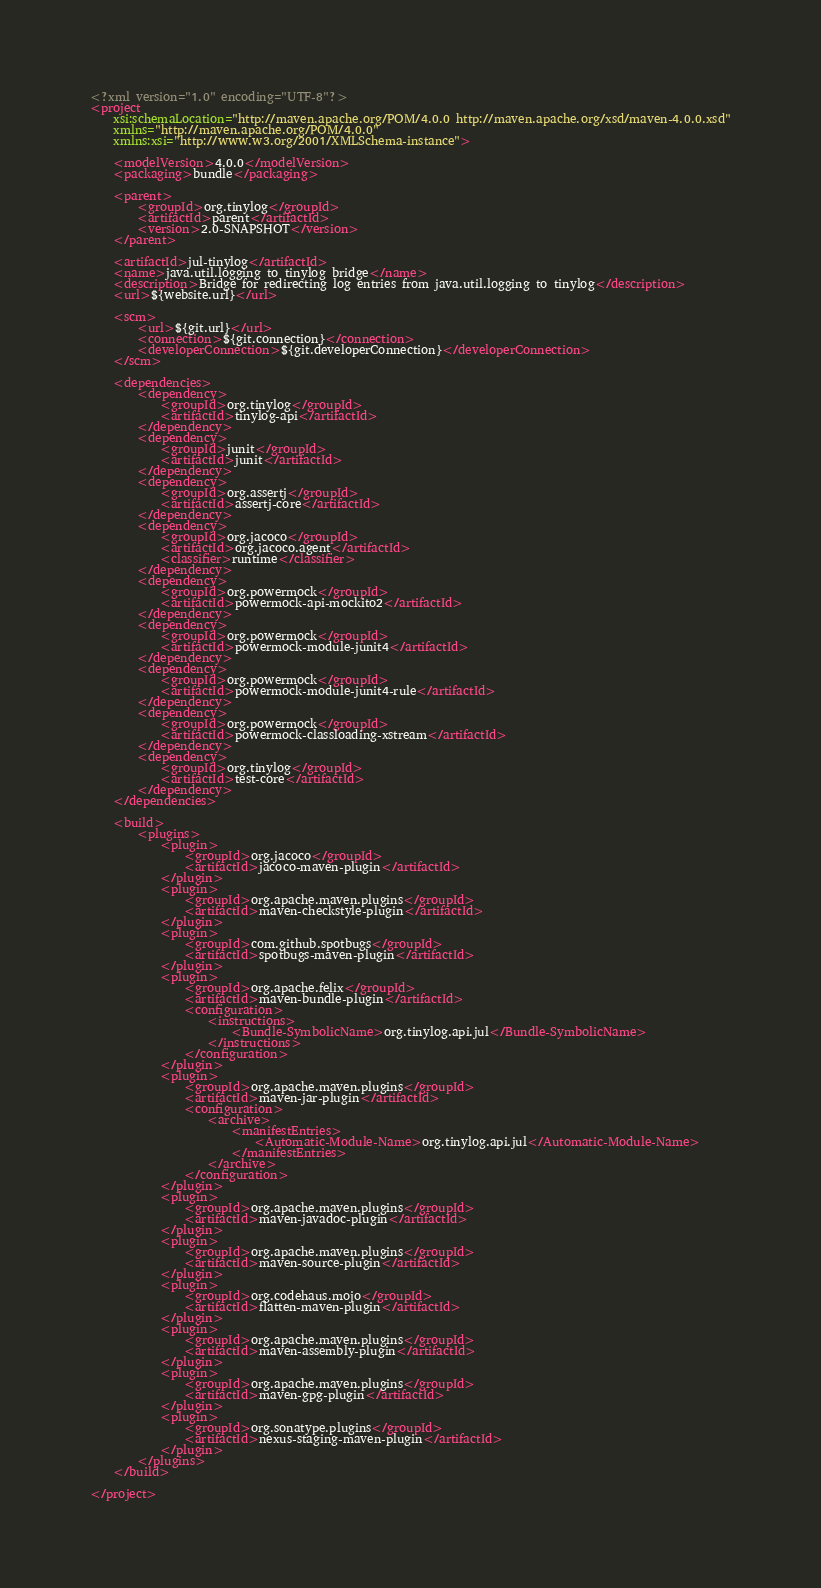Convert code to text. <code><loc_0><loc_0><loc_500><loc_500><_XML_><?xml version="1.0" encoding="UTF-8"?>
<project
	xsi:schemaLocation="http://maven.apache.org/POM/4.0.0 http://maven.apache.org/xsd/maven-4.0.0.xsd"
	xmlns="http://maven.apache.org/POM/4.0.0"
	xmlns:xsi="http://www.w3.org/2001/XMLSchema-instance">

	<modelVersion>4.0.0</modelVersion>
	<packaging>bundle</packaging>

	<parent>
		<groupId>org.tinylog</groupId>
		<artifactId>parent</artifactId>
		<version>2.0-SNAPSHOT</version>
	</parent>

	<artifactId>jul-tinylog</artifactId>
	<name>java.util.logging to tinylog bridge</name>
	<description>Bridge for redirecting log entries from java.util.logging to tinylog</description>
	<url>${website.url}</url>

	<scm>
		<url>${git.url}</url>
		<connection>${git.connection}</connection>
		<developerConnection>${git.developerConnection}</developerConnection>
	</scm>

	<dependencies>
		<dependency>
			<groupId>org.tinylog</groupId>
			<artifactId>tinylog-api</artifactId>
		</dependency>
		<dependency>
			<groupId>junit</groupId>
			<artifactId>junit</artifactId>
		</dependency>
		<dependency>
			<groupId>org.assertj</groupId>
			<artifactId>assertj-core</artifactId>
		</dependency>
		<dependency>
			<groupId>org.jacoco</groupId>
			<artifactId>org.jacoco.agent</artifactId>
			<classifier>runtime</classifier>
		</dependency>
		<dependency>
			<groupId>org.powermock</groupId>
			<artifactId>powermock-api-mockito2</artifactId>
		</dependency>
		<dependency>
			<groupId>org.powermock</groupId>
			<artifactId>powermock-module-junit4</artifactId>
		</dependency>
		<dependency>
			<groupId>org.powermock</groupId>
			<artifactId>powermock-module-junit4-rule</artifactId>
		</dependency>
		<dependency>
			<groupId>org.powermock</groupId>
			<artifactId>powermock-classloading-xstream</artifactId>
		</dependency>
		<dependency>
			<groupId>org.tinylog</groupId>
			<artifactId>test-core</artifactId>
		</dependency>
	</dependencies>

	<build>
		<plugins>
			<plugin>
				<groupId>org.jacoco</groupId>
				<artifactId>jacoco-maven-plugin</artifactId>
			</plugin>
			<plugin>
				<groupId>org.apache.maven.plugins</groupId>
				<artifactId>maven-checkstyle-plugin</artifactId>
			</plugin>
			<plugin>
				<groupId>com.github.spotbugs</groupId>
				<artifactId>spotbugs-maven-plugin</artifactId>
			</plugin>
			<plugin>
				<groupId>org.apache.felix</groupId>
				<artifactId>maven-bundle-plugin</artifactId>
				<configuration>
					<instructions>
						<Bundle-SymbolicName>org.tinylog.api.jul</Bundle-SymbolicName>
					</instructions>
				</configuration>
			</plugin>
			<plugin>
				<groupId>org.apache.maven.plugins</groupId>
				<artifactId>maven-jar-plugin</artifactId>
				<configuration>
					<archive>
						<manifestEntries>
							<Automatic-Module-Name>org.tinylog.api.jul</Automatic-Module-Name>
						</manifestEntries>
					</archive>
				</configuration>
			</plugin>
			<plugin>
				<groupId>org.apache.maven.plugins</groupId>
				<artifactId>maven-javadoc-plugin</artifactId>
			</plugin>
			<plugin>
				<groupId>org.apache.maven.plugins</groupId>
				<artifactId>maven-source-plugin</artifactId>
			</plugin>
			<plugin>
				<groupId>org.codehaus.mojo</groupId>
				<artifactId>flatten-maven-plugin</artifactId>
			</plugin>
			<plugin>
				<groupId>org.apache.maven.plugins</groupId>
				<artifactId>maven-assembly-plugin</artifactId>
			</plugin>
			<plugin>
				<groupId>org.apache.maven.plugins</groupId>
				<artifactId>maven-gpg-plugin</artifactId>
			</plugin>
			<plugin>
				<groupId>org.sonatype.plugins</groupId>
				<artifactId>nexus-staging-maven-plugin</artifactId>
			</plugin>
		</plugins>
	</build>

</project>
</code> 